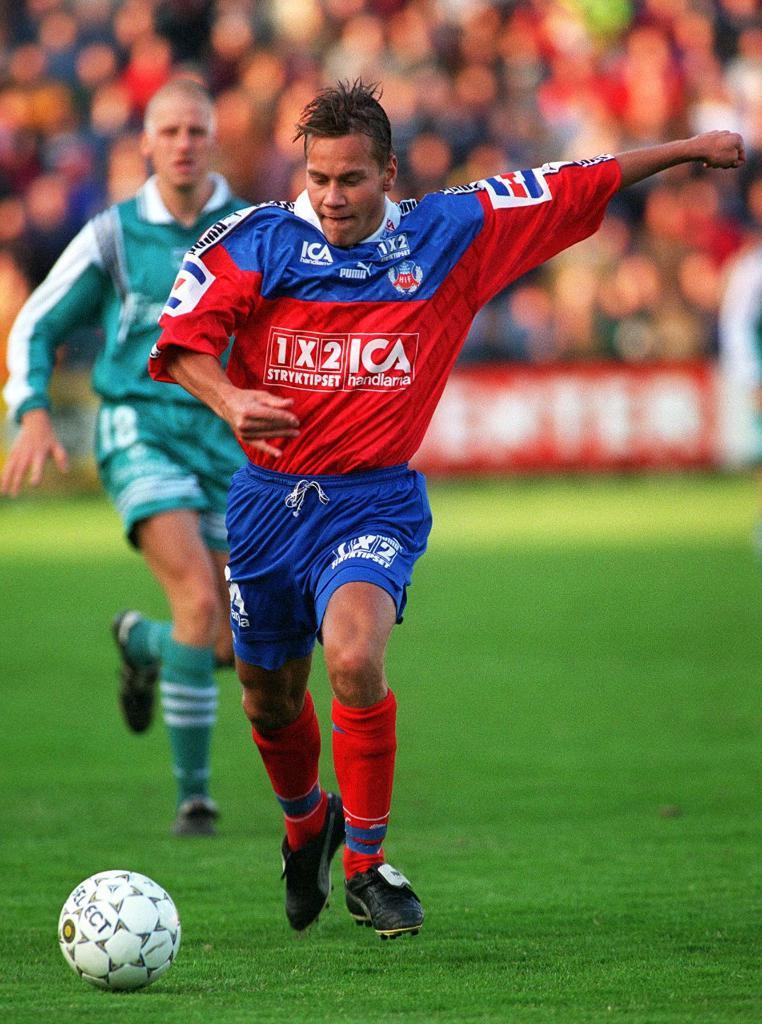Provide a one-sentence caption for the provided image. A man in a red and blue ICA soccer uniform runs up to kick a ball. 